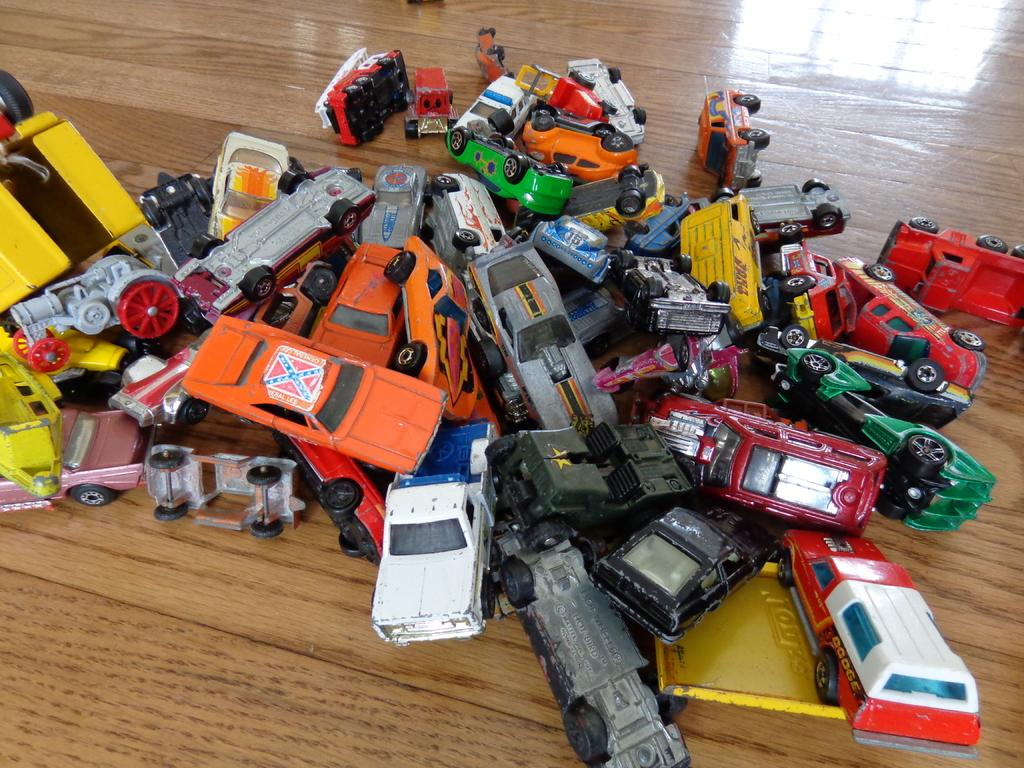What type of toys are present in the image? There are toy cars in the image. Can you describe the colors of the toy cars? The toy cars are of different colors. Where are the toy cars located in the image? The toy cars are in the center of the image. What type of creature is sitting on top of the toy cars in the image? There is no creature present in the image; it only features toy cars of different colors in the center. 